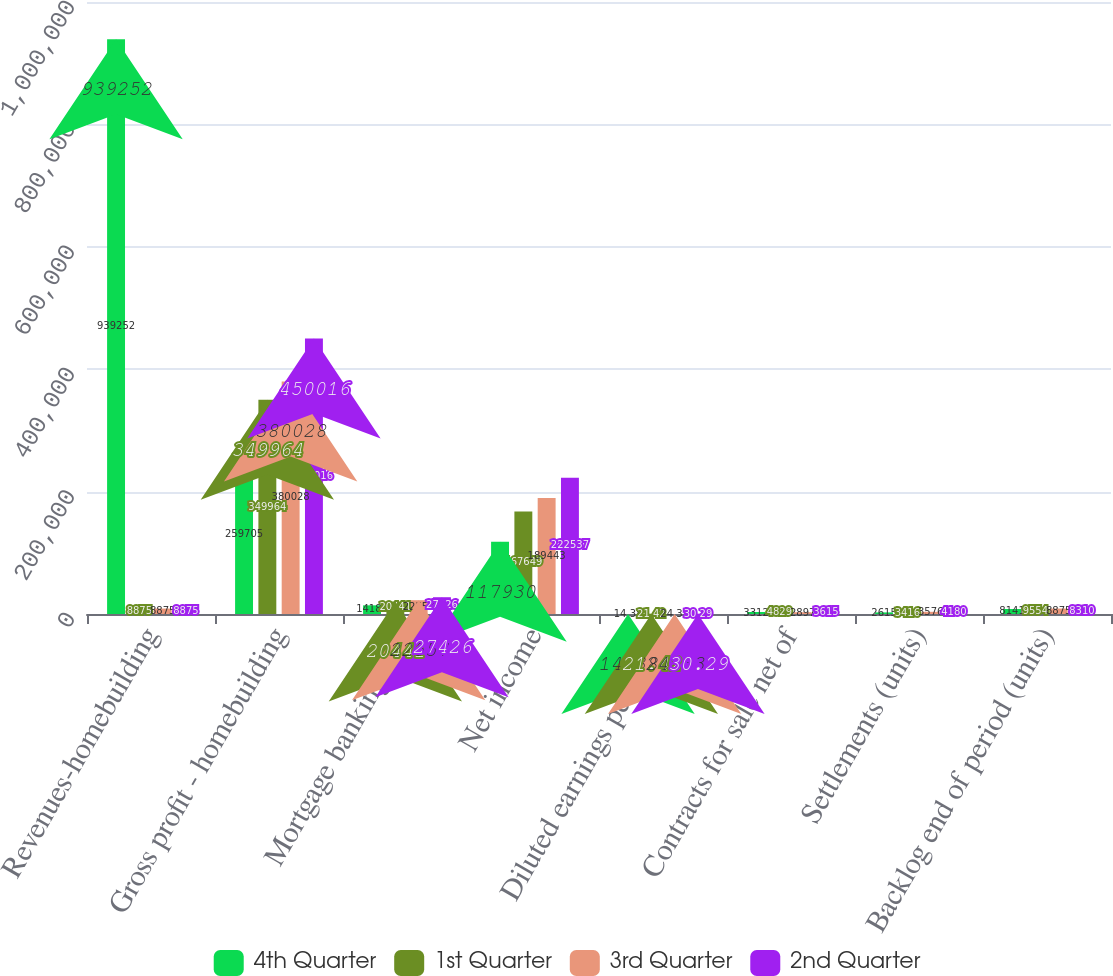Convert chart. <chart><loc_0><loc_0><loc_500><loc_500><stacked_bar_chart><ecel><fcel>Revenues-homebuilding<fcel>Gross profit - homebuilding<fcel>Mortgage banking fees<fcel>Net income<fcel>Diluted earnings per share<fcel>Contracts for sale net of<fcel>Settlements (units)<fcel>Backlog end of period (units)<nl><fcel>4th Quarter<fcel>939252<fcel>259705<fcel>14180<fcel>117930<fcel>14.38<fcel>3312<fcel>2615<fcel>8141<nl><fcel>1st Quarter<fcel>8875<fcel>349964<fcel>20441<fcel>167649<fcel>21.42<fcel>4829<fcel>3416<fcel>9554<nl><fcel>3rd Quarter<fcel>8875<fcel>380028<fcel>22557<fcel>189443<fcel>24.33<fcel>2897<fcel>3576<fcel>8875<nl><fcel>2nd Quarter<fcel>8875<fcel>450016<fcel>27426<fcel>222537<fcel>30.29<fcel>3615<fcel>4180<fcel>8310<nl></chart> 